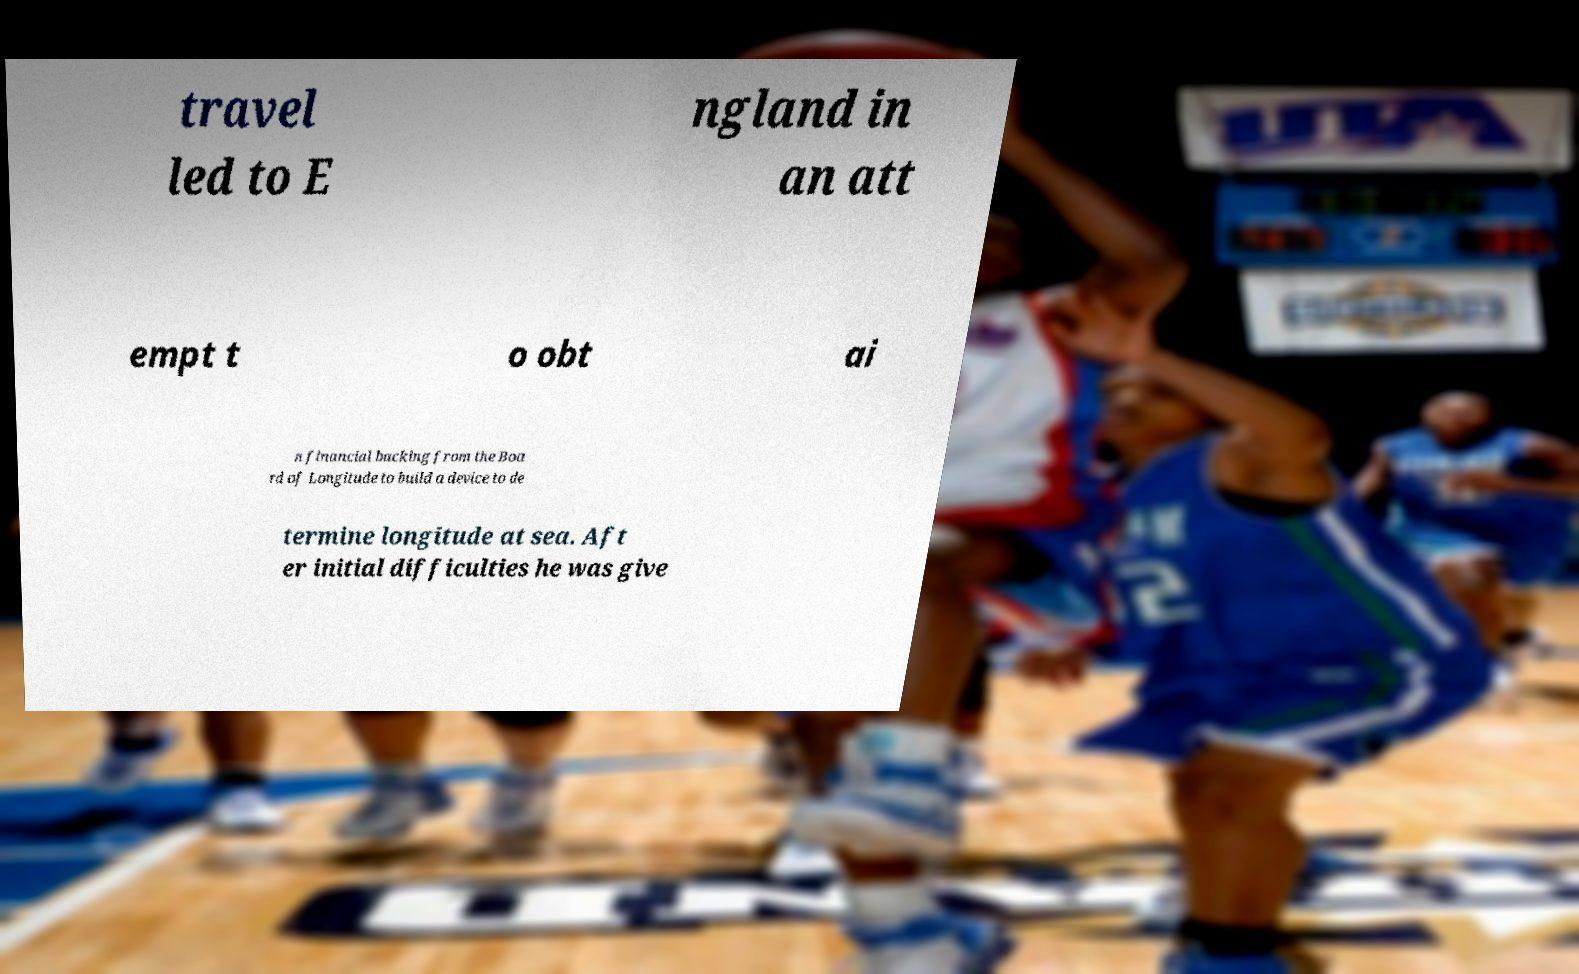I need the written content from this picture converted into text. Can you do that? travel led to E ngland in an att empt t o obt ai n financial backing from the Boa rd of Longitude to build a device to de termine longitude at sea. Aft er initial difficulties he was give 